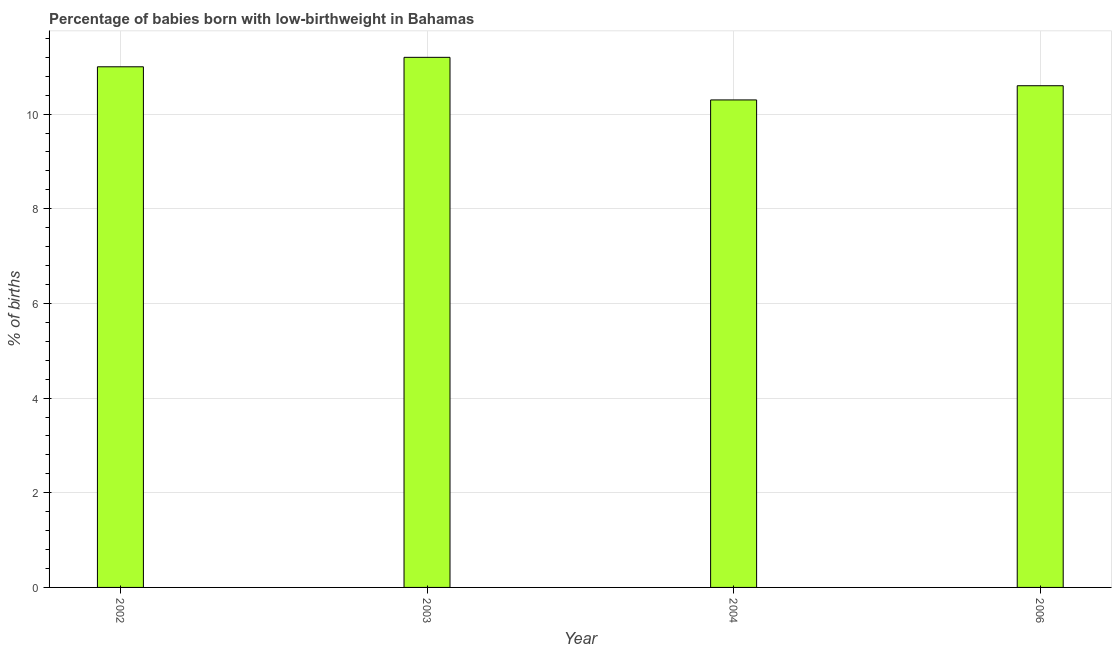Does the graph contain any zero values?
Offer a very short reply. No. Does the graph contain grids?
Offer a very short reply. Yes. What is the title of the graph?
Give a very brief answer. Percentage of babies born with low-birthweight in Bahamas. What is the label or title of the Y-axis?
Offer a very short reply. % of births. What is the percentage of babies who were born with low-birthweight in 2004?
Keep it short and to the point. 10.3. In which year was the percentage of babies who were born with low-birthweight minimum?
Give a very brief answer. 2004. What is the sum of the percentage of babies who were born with low-birthweight?
Ensure brevity in your answer.  43.1. What is the difference between the percentage of babies who were born with low-birthweight in 2002 and 2004?
Offer a terse response. 0.7. What is the average percentage of babies who were born with low-birthweight per year?
Make the answer very short. 10.78. What is the median percentage of babies who were born with low-birthweight?
Ensure brevity in your answer.  10.8. In how many years, is the percentage of babies who were born with low-birthweight greater than 8 %?
Ensure brevity in your answer.  4. Do a majority of the years between 2003 and 2006 (inclusive) have percentage of babies who were born with low-birthweight greater than 1.6 %?
Provide a succinct answer. Yes. What is the ratio of the percentage of babies who were born with low-birthweight in 2003 to that in 2004?
Your response must be concise. 1.09. Is the percentage of babies who were born with low-birthweight in 2002 less than that in 2006?
Provide a short and direct response. No. Is the difference between the percentage of babies who were born with low-birthweight in 2004 and 2006 greater than the difference between any two years?
Your answer should be compact. No. What is the difference between the highest and the second highest percentage of babies who were born with low-birthweight?
Offer a very short reply. 0.2. Is the sum of the percentage of babies who were born with low-birthweight in 2002 and 2004 greater than the maximum percentage of babies who were born with low-birthweight across all years?
Your answer should be very brief. Yes. What is the difference between the highest and the lowest percentage of babies who were born with low-birthweight?
Provide a succinct answer. 0.9. How many years are there in the graph?
Ensure brevity in your answer.  4. What is the % of births in 2003?
Ensure brevity in your answer.  11.2. What is the % of births in 2004?
Your answer should be compact. 10.3. What is the % of births of 2006?
Provide a short and direct response. 10.6. What is the difference between the % of births in 2002 and 2003?
Your answer should be very brief. -0.2. What is the difference between the % of births in 2002 and 2004?
Provide a short and direct response. 0.7. What is the difference between the % of births in 2003 and 2006?
Ensure brevity in your answer.  0.6. What is the difference between the % of births in 2004 and 2006?
Your answer should be very brief. -0.3. What is the ratio of the % of births in 2002 to that in 2004?
Your answer should be compact. 1.07. What is the ratio of the % of births in 2002 to that in 2006?
Ensure brevity in your answer.  1.04. What is the ratio of the % of births in 2003 to that in 2004?
Provide a succinct answer. 1.09. What is the ratio of the % of births in 2003 to that in 2006?
Provide a short and direct response. 1.06. 